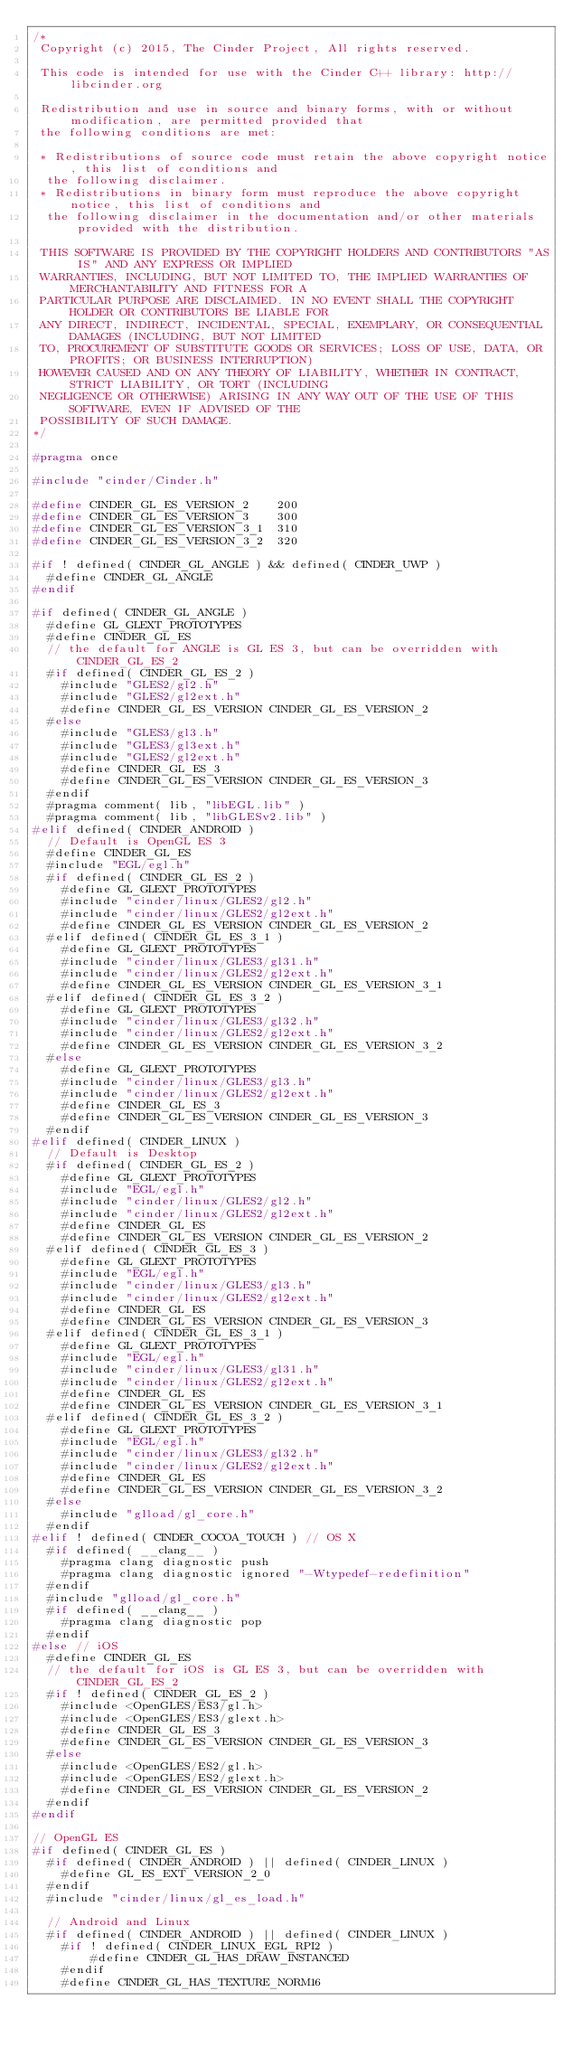Convert code to text. <code><loc_0><loc_0><loc_500><loc_500><_C_>/*
 Copyright (c) 2015, The Cinder Project, All rights reserved.

 This code is intended for use with the Cinder C++ library: http://libcinder.org

 Redistribution and use in source and binary forms, with or without modification, are permitted provided that
 the following conditions are met:

 * Redistributions of source code must retain the above copyright notice, this list of conditions and
	the following disclaimer.
 * Redistributions in binary form must reproduce the above copyright notice, this list of conditions and
	the following disclaimer in the documentation and/or other materials provided with the distribution.

 THIS SOFTWARE IS PROVIDED BY THE COPYRIGHT HOLDERS AND CONTRIBUTORS "AS IS" AND ANY EXPRESS OR IMPLIED
 WARRANTIES, INCLUDING, BUT NOT LIMITED TO, THE IMPLIED WARRANTIES OF MERCHANTABILITY AND FITNESS FOR A
 PARTICULAR PURPOSE ARE DISCLAIMED. IN NO EVENT SHALL THE COPYRIGHT HOLDER OR CONTRIBUTORS BE LIABLE FOR
 ANY DIRECT, INDIRECT, INCIDENTAL, SPECIAL, EXEMPLARY, OR CONSEQUENTIAL DAMAGES (INCLUDING, BUT NOT LIMITED
 TO, PROCUREMENT OF SUBSTITUTE GOODS OR SERVICES; LOSS OF USE, DATA, OR PROFITS; OR BUSINESS INTERRUPTION)
 HOWEVER CAUSED AND ON ANY THEORY OF LIABILITY, WHETHER IN CONTRACT, STRICT LIABILITY, OR TORT (INCLUDING
 NEGLIGENCE OR OTHERWISE) ARISING IN ANY WAY OUT OF THE USE OF THIS SOFTWARE, EVEN IF ADVISED OF THE
 POSSIBILITY OF SUCH DAMAGE.
*/

#pragma once

#include "cinder/Cinder.h"

#define CINDER_GL_ES_VERSION_2		200
#define CINDER_GL_ES_VERSION_3		300
#define CINDER_GL_ES_VERSION_3_1	310
#define CINDER_GL_ES_VERSION_3_2	320

#if ! defined( CINDER_GL_ANGLE ) && defined( CINDER_UWP )
	#define CINDER_GL_ANGLE
#endif

#if defined( CINDER_GL_ANGLE )
	#define GL_GLEXT_PROTOTYPES
	#define CINDER_GL_ES
	// the default for ANGLE is GL ES 3, but can be overridden with CINDER_GL_ES_2
	#if defined( CINDER_GL_ES_2 )
		#include "GLES2/gl2.h"
		#include "GLES2/gl2ext.h"
 		#define CINDER_GL_ES_VERSION CINDER_GL_ES_VERSION_2
	#else
		#include "GLES3/gl3.h"
		#include "GLES3/gl3ext.h"
		#include "GLES2/gl2ext.h"
		#define CINDER_GL_ES_3
 		#define CINDER_GL_ES_VERSION CINDER_GL_ES_VERSION_3
	#endif
	#pragma comment( lib, "libEGL.lib" )
	#pragma comment( lib, "libGLESv2.lib" )
#elif defined( CINDER_ANDROID )
 	// Default is OpenGL ES 3
	#define CINDER_GL_ES
 	#include "EGL/egl.h" 
 	#if defined( CINDER_GL_ES_2 )
 		#define GL_GLEXT_PROTOTYPES
		#include "cinder/linux/GLES2/gl2.h"
		#include "cinder/linux/GLES2/gl2ext.h"
 		#define CINDER_GL_ES_VERSION CINDER_GL_ES_VERSION_2
	#elif defined( CINDER_GL_ES_3_1 )
		#define GL_GLEXT_PROTOTYPES
		#include "cinder/linux/GLES3/gl31.h"
		#include "cinder/linux/GLES2/gl2ext.h"
		#define CINDER_GL_ES_VERSION CINDER_GL_ES_VERSION_3_1
	#elif defined( CINDER_GL_ES_3_2 )
		#define GL_GLEXT_PROTOTYPES
		#include "cinder/linux/GLES3/gl32.h"
		#include "cinder/linux/GLES2/gl2ext.h"  
		#define CINDER_GL_ES_VERSION CINDER_GL_ES_VERSION_3_2
 	#else
 		#define GL_GLEXT_PROTOTYPES
		#include "cinder/linux/GLES3/gl3.h"
		#include "cinder/linux/GLES2/gl2ext.h"
		#define CINDER_GL_ES_3
 		#define CINDER_GL_ES_VERSION CINDER_GL_ES_VERSION_3
 	#endif
#elif defined( CINDER_LINUX )
	// Default is Desktop
 	#if defined( CINDER_GL_ES_2 )
 		#define GL_GLEXT_PROTOTYPES
 		#include "EGL/egl.h" 
		#include "cinder/linux/GLES2/gl2.h"
		#include "cinder/linux/GLES2/gl2ext.h"
 		#define CINDER_GL_ES
 		#define CINDER_GL_ES_VERSION CINDER_GL_ES_VERSION_2
 	#elif defined( CINDER_GL_ES_3 )
 		#define GL_GLEXT_PROTOTYPES
 		#include "EGL/egl.h"
		#include "cinder/linux/GLES3/gl3.h"
		#include "cinder/linux/GLES2/gl2ext.h"
 		#define CINDER_GL_ES
 		#define CINDER_GL_ES_VERSION CINDER_GL_ES_VERSION_3
	#elif defined( CINDER_GL_ES_3_1 )
		#define GL_GLEXT_PROTOTYPES
 		#include "EGL/egl.h" 
		#include "cinder/linux/GLES3/gl31.h"
		#include "cinder/linux/GLES2/gl2ext.h"
 		#define CINDER_GL_ES
		#define CINDER_GL_ES_VERSION CINDER_GL_ES_VERSION_3_1
	#elif defined( CINDER_GL_ES_3_2 )
		#define GL_GLEXT_PROTOTYPES
 		#include "EGL/egl.h" 
		#include "cinder/linux/GLES3/gl32.h"
		#include "cinder/linux/GLES2/gl2ext.h" 
 		#define CINDER_GL_ES
		#define CINDER_GL_ES_VERSION CINDER_GL_ES_VERSION_3_2
 	#else
 		#include "glload/gl_core.h"
 	#endif
#elif ! defined( CINDER_COCOA_TOUCH ) // OS X
	#if defined( __clang__ )
		#pragma clang diagnostic push
		#pragma clang diagnostic ignored "-Wtypedef-redefinition"
	#endif
	#include "glload/gl_core.h"
	#if defined( __clang__ )
		#pragma clang diagnostic pop
	#endif
#else // iOS
	#define CINDER_GL_ES
	// the default for iOS is GL ES 3, but can be overridden with CINDER_GL_ES_2
	#if ! defined( CINDER_GL_ES_2 )
		#include <OpenGLES/ES3/gl.h>
		#include <OpenGLES/ES3/glext.h>
		#define CINDER_GL_ES_3
 		#define CINDER_GL_ES_VERSION CINDER_GL_ES_VERSION_3
	#else
		#include <OpenGLES/ES2/gl.h>
		#include <OpenGLES/ES2/glext.h>
 		#define CINDER_GL_ES_VERSION CINDER_GL_ES_VERSION_2		
	#endif
#endif

// OpenGL ES
#if defined( CINDER_GL_ES )
	#if defined( CINDER_ANDROID ) || defined( CINDER_LINUX ) 	
		#define GL_ES_EXT_VERSION_2_0
	#endif 
	#include "cinder/linux/gl_es_load.h"

	// Android and Linux
	#if defined( CINDER_ANDROID ) || defined( CINDER_LINUX )
		#if ! defined( CINDER_LINUX_EGL_RPI2 )
		    #define CINDER_GL_HAS_DRAW_INSTANCED
		#endif
		#define CINDER_GL_HAS_TEXTURE_NORM16
</code> 